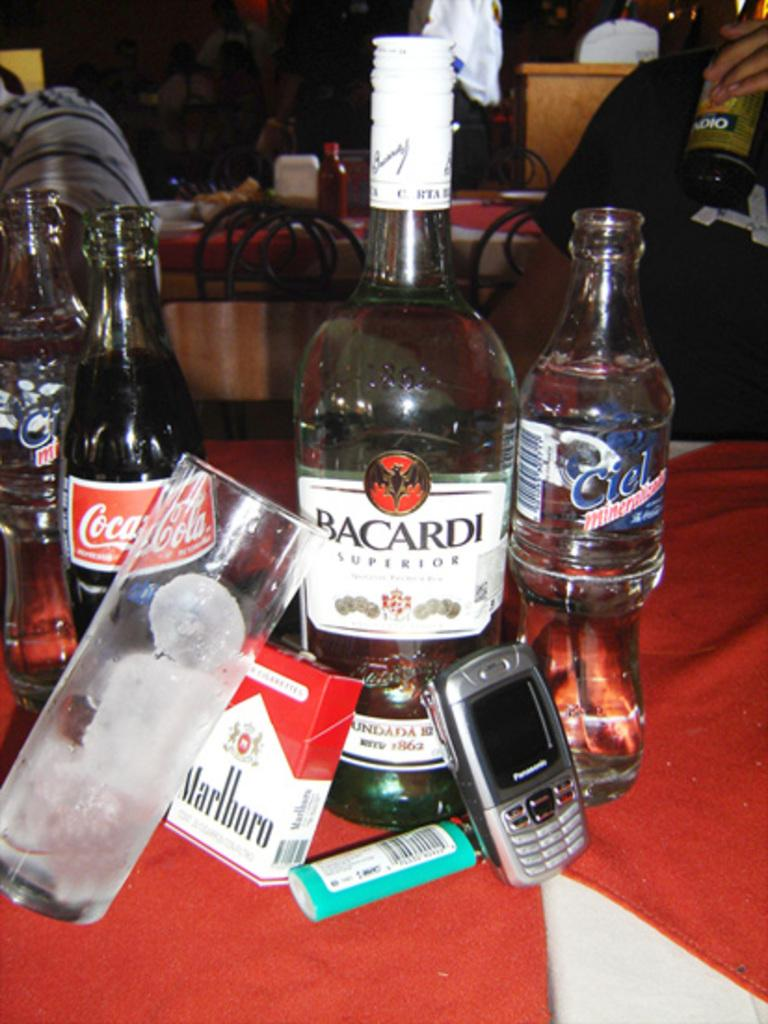Provide a one-sentence caption for the provided image. A group of bottles including Bacardi Superior are next to a cellphone, a lighter, and a pack of Marlboro's. 